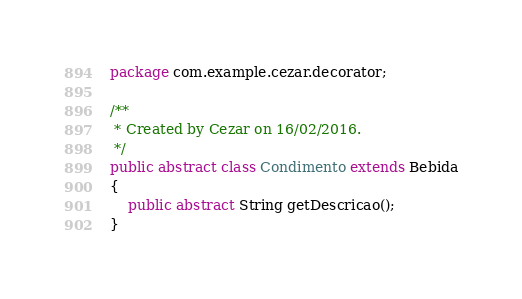Convert code to text. <code><loc_0><loc_0><loc_500><loc_500><_Java_>package com.example.cezar.decorator;

/**
 * Created by Cezar on 16/02/2016.
 */
public abstract class Condimento extends Bebida
{
    public abstract String getDescricao();
}
</code> 